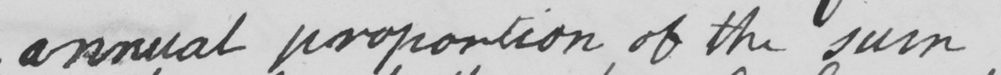Can you read and transcribe this handwriting? annual proportion of the sum 